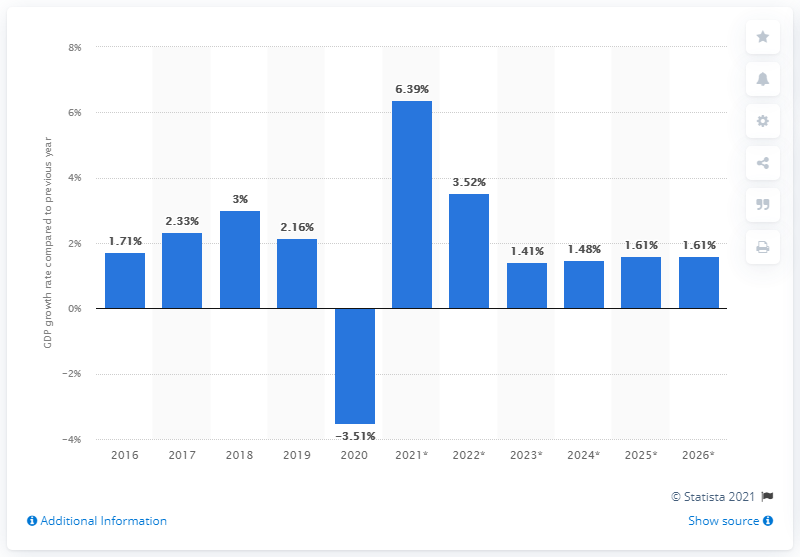Identify some key points in this picture. In 2019, the real gross domestic product in the United States grew by 2.16%. 